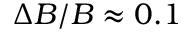<formula> <loc_0><loc_0><loc_500><loc_500>\Delta B / B \approx 0 . 1</formula> 